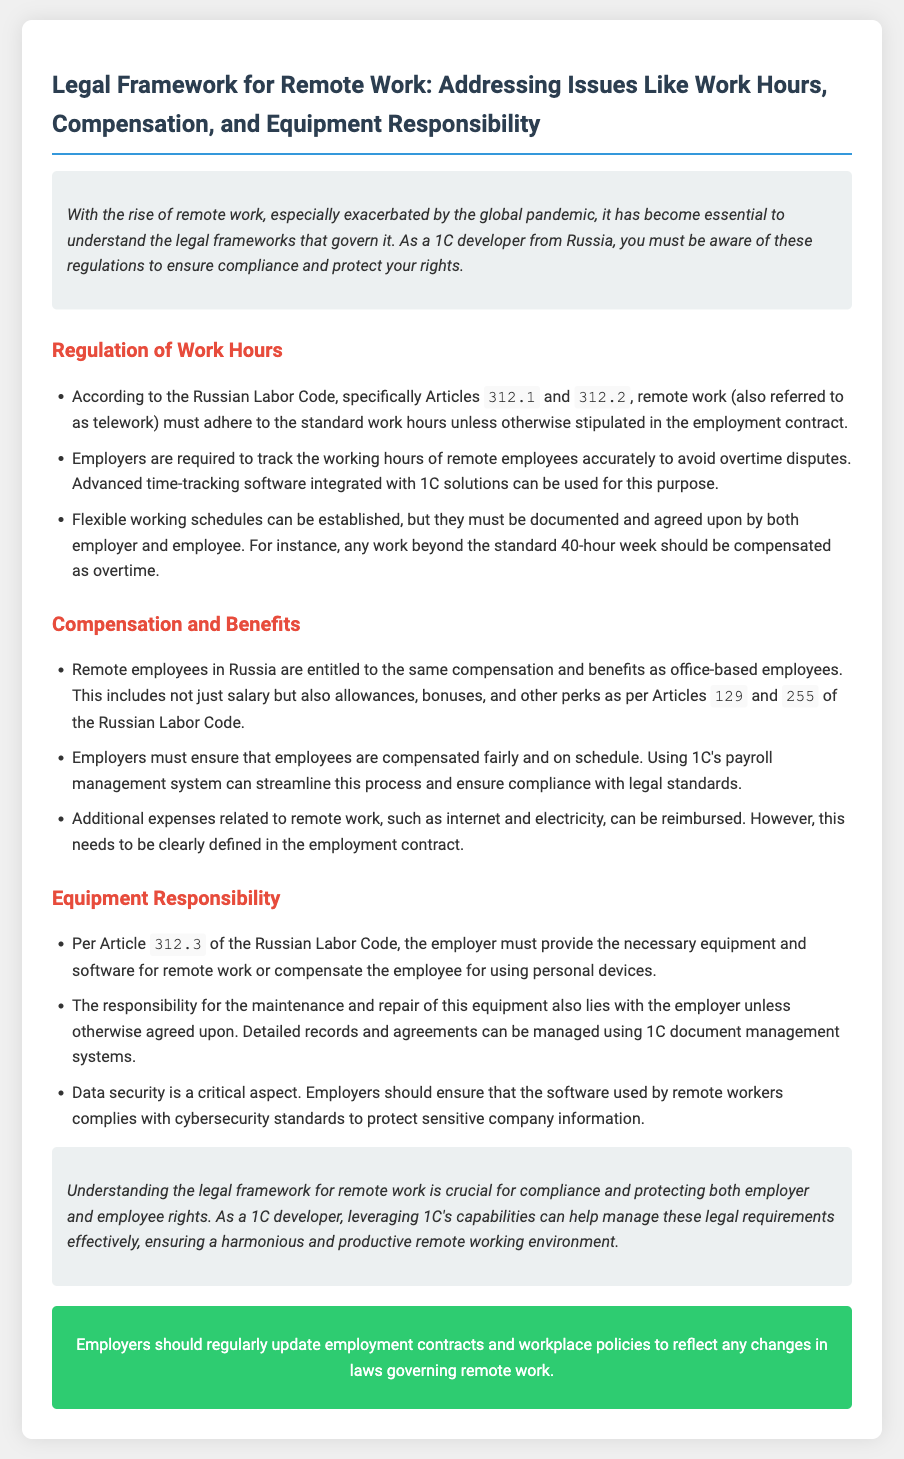What are the articles related to work hours? The articles mentioned in the document regarding work hours are 312.1 and 312.2.
Answer: 312.1, 312.2 What is the maximum standard work week? The document states that the standard work week is 40 hours unless otherwise agreed.
Answer: 40 hours What benefits are remote employees entitled to? Remote employees are entitled to the same compensation and benefits as office-based employees.
Answer: Same compensation and benefits Who has the responsibility for equipment maintenance? According to the document, maintenance responsibility lies with the employer unless agreed otherwise.
Answer: Employer What should employers track for remote employees? Employers must track the working hours of remote employees to avoid overtime disputes.
Answer: Working hours What articles cover compensation and benefits? The articles detailing compensation and benefits are 129 and 255 of the Russian Labor Code.
Answer: 129, 255 What must be defined in the employment contract regarding expenses? The reimbursement of additional expenses related to remote work must be clearly defined in the employment contract.
Answer: Reimbursement of expenses What aspect of cybersecurity is emphasized? Data security compliance with cybersecurity standards for software used by remote workers is a critical aspect.
Answer: Data security 